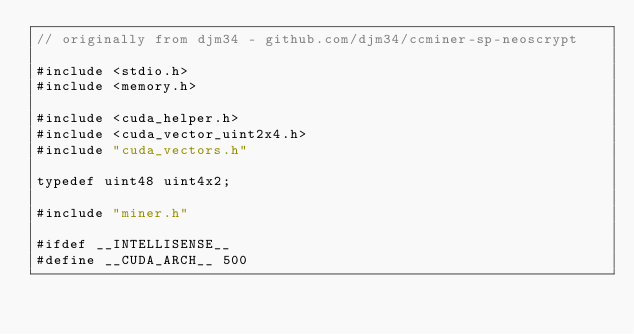Convert code to text. <code><loc_0><loc_0><loc_500><loc_500><_Cuda_>// originally from djm34 - github.com/djm34/ccminer-sp-neoscrypt

#include <stdio.h>
#include <memory.h>

#include <cuda_helper.h>
#include <cuda_vector_uint2x4.h>
#include "cuda_vectors.h"

typedef uint48 uint4x2;

#include "miner.h"

#ifdef __INTELLISENSE__
#define __CUDA_ARCH__ 500</code> 